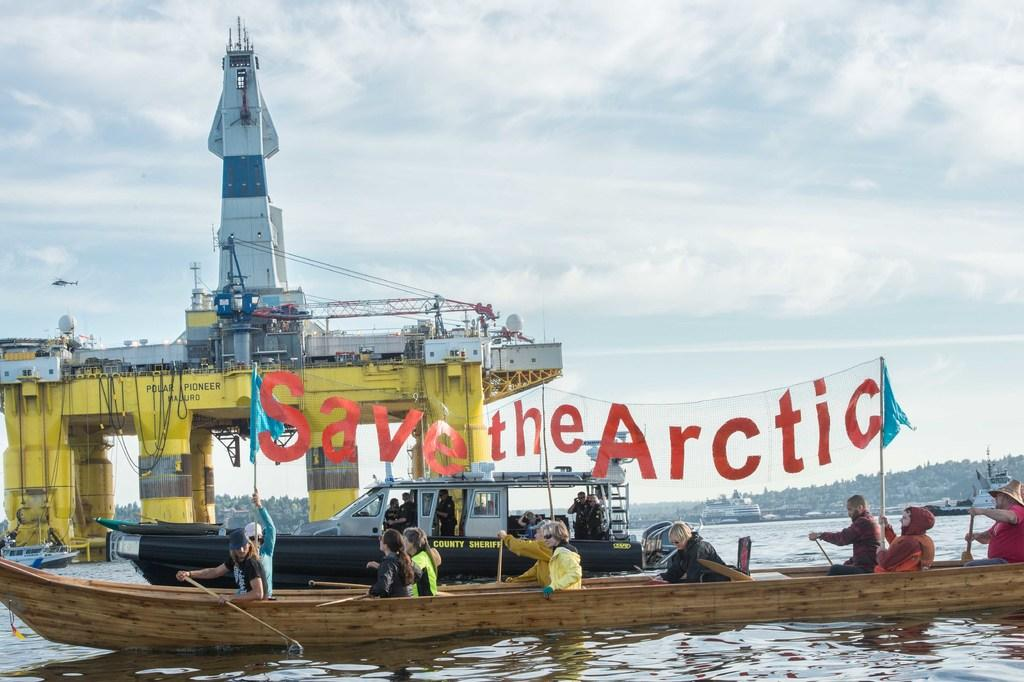What is happening on the water in the image? There are boats on the water in the image. What structure can be seen in the image? There is a bridge in the image. Who or what is present in the image? There are people in the image. What can be seen flying in the image? There are flags in the image. What type of natural environment is visible in the background of the image? There are trees visible in the background of the image. What part of the sky is visible in the image? The sky is visible in the background of the image. What else can be seen in the background of the image? There are some unspecified objects in the background of the image. Is there any text present in the image? Yes, there is text present in the image. How many sheep are visible in the image? There are no sheep present in the image. What type of rock is being used as a base for the bridge in the image? There is no mention of a rock being used as a base for the bridge in the image. 